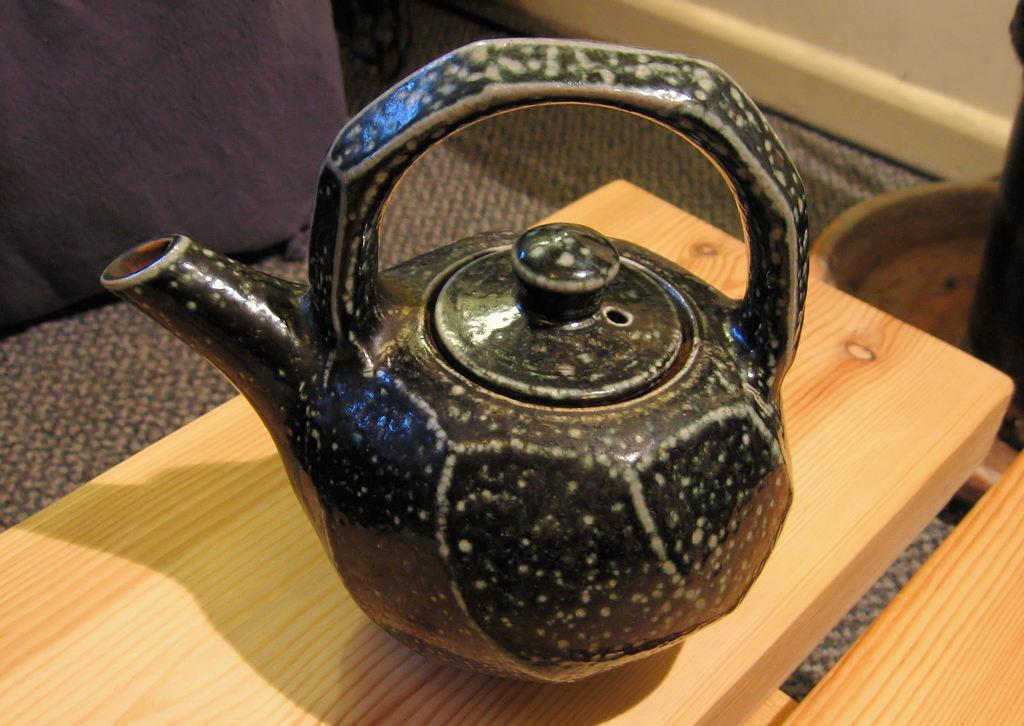What piece of furniture is present in the image? There is a table in the image. What object is placed on the table? There is a kettle on the table. What is the color of the kettle? The kettle is black in color. What type of art is displayed on the table in the image? There is no art displayed on the table in the image; it only features a black kettle. 